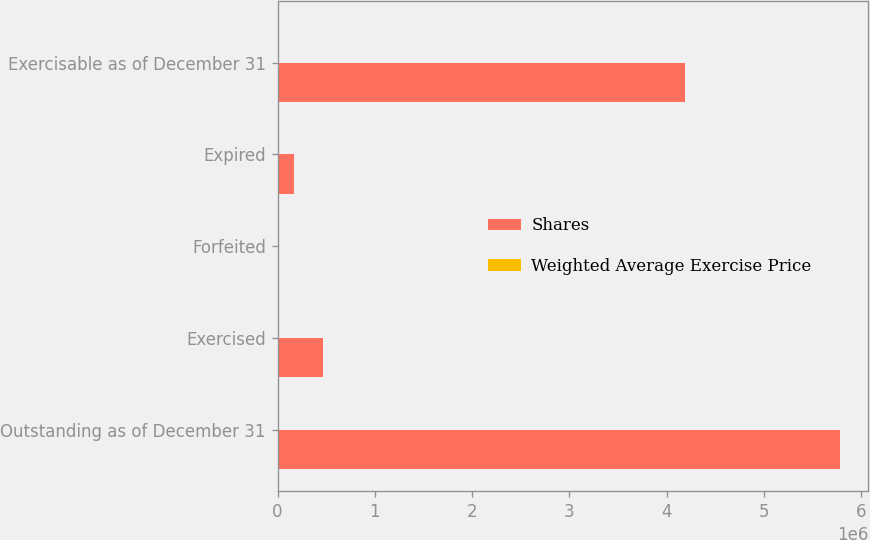Convert chart. <chart><loc_0><loc_0><loc_500><loc_500><stacked_bar_chart><ecel><fcel>Outstanding as of December 31<fcel>Exercised<fcel>Forfeited<fcel>Expired<fcel>Exercisable as of December 31<nl><fcel>Shares<fcel>5.7841e+06<fcel>462647<fcel>18109<fcel>167878<fcel>4.18884e+06<nl><fcel>Weighted Average Exercise Price<fcel>38.79<fcel>26.5<fcel>33.07<fcel>41.72<fcel>41.2<nl></chart> 